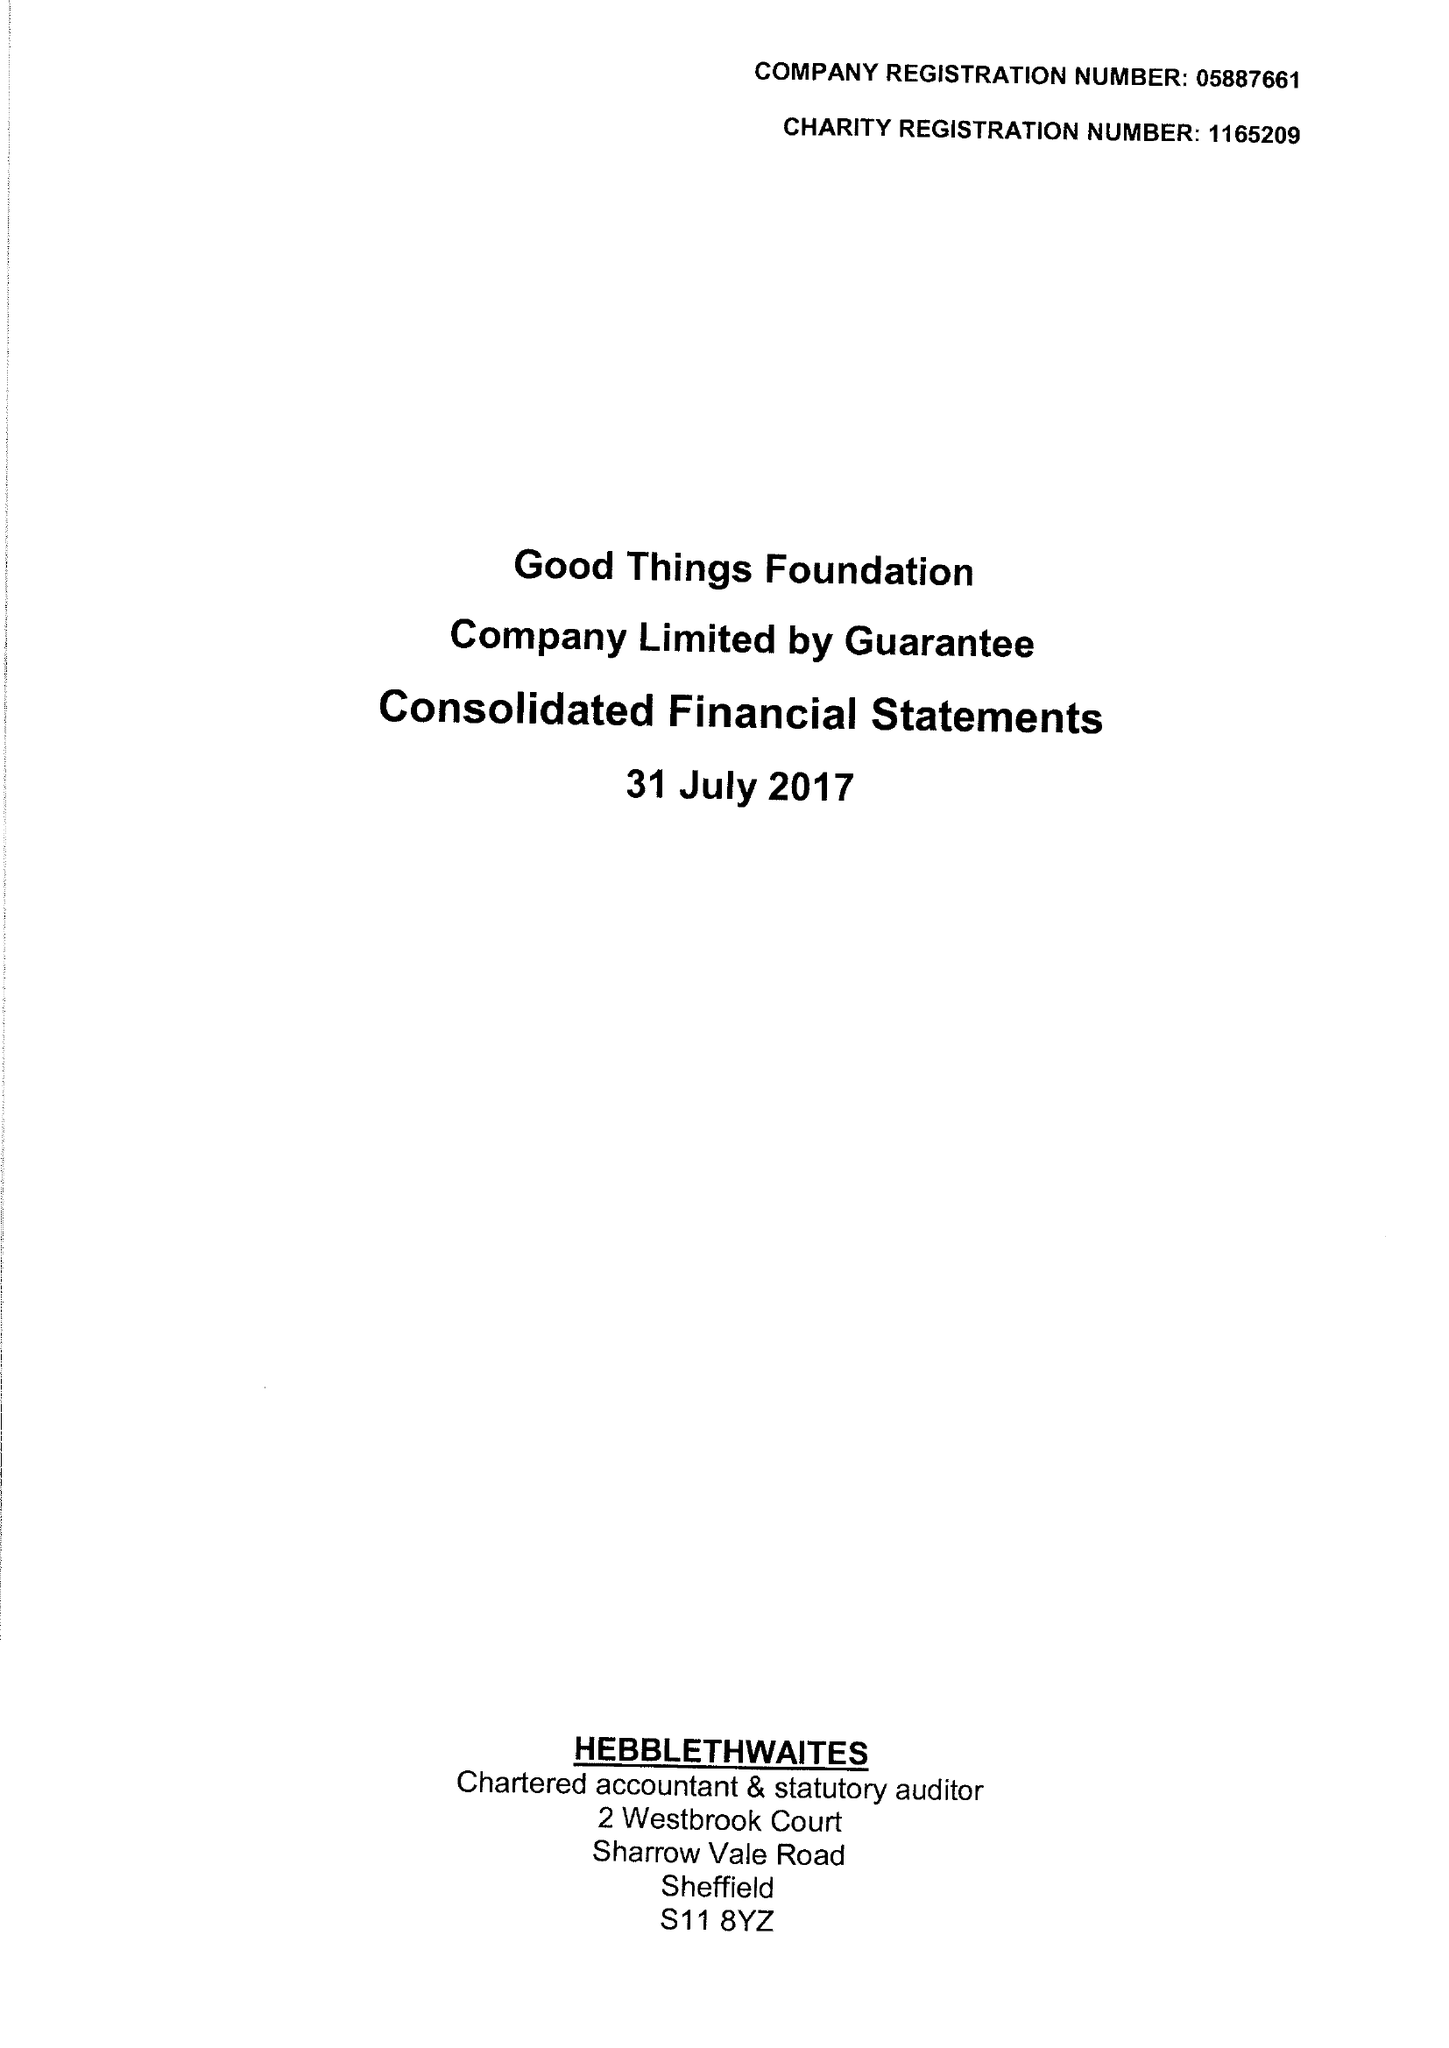What is the value for the income_annually_in_british_pounds?
Answer the question using a single word or phrase. 5859991.00 